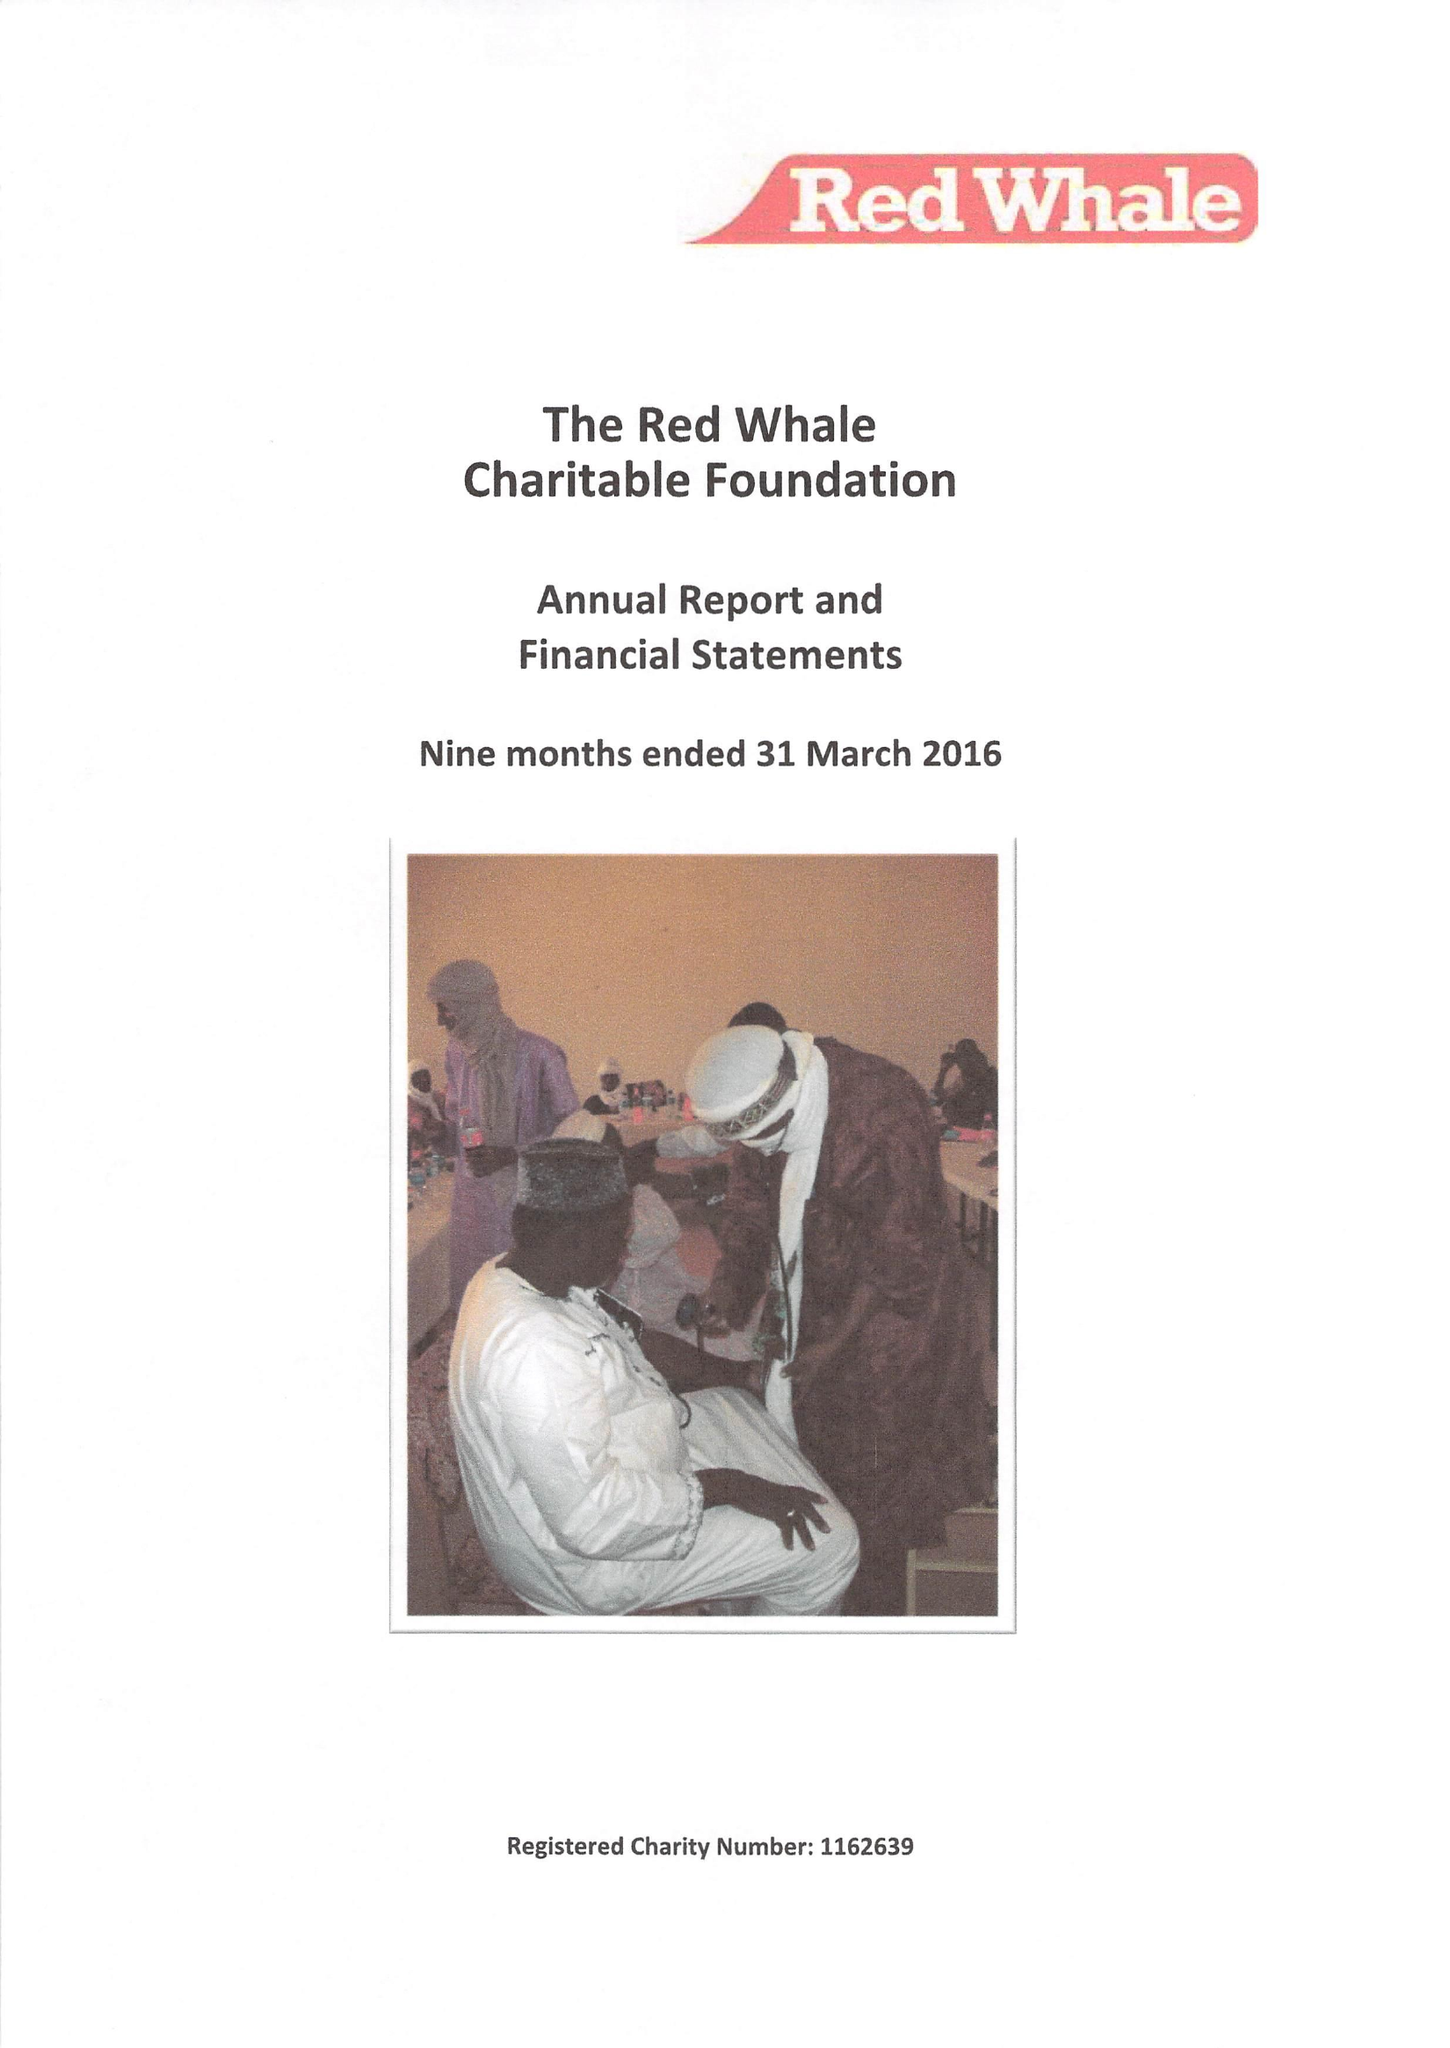What is the value for the address__post_town?
Answer the question using a single word or phrase. READING 